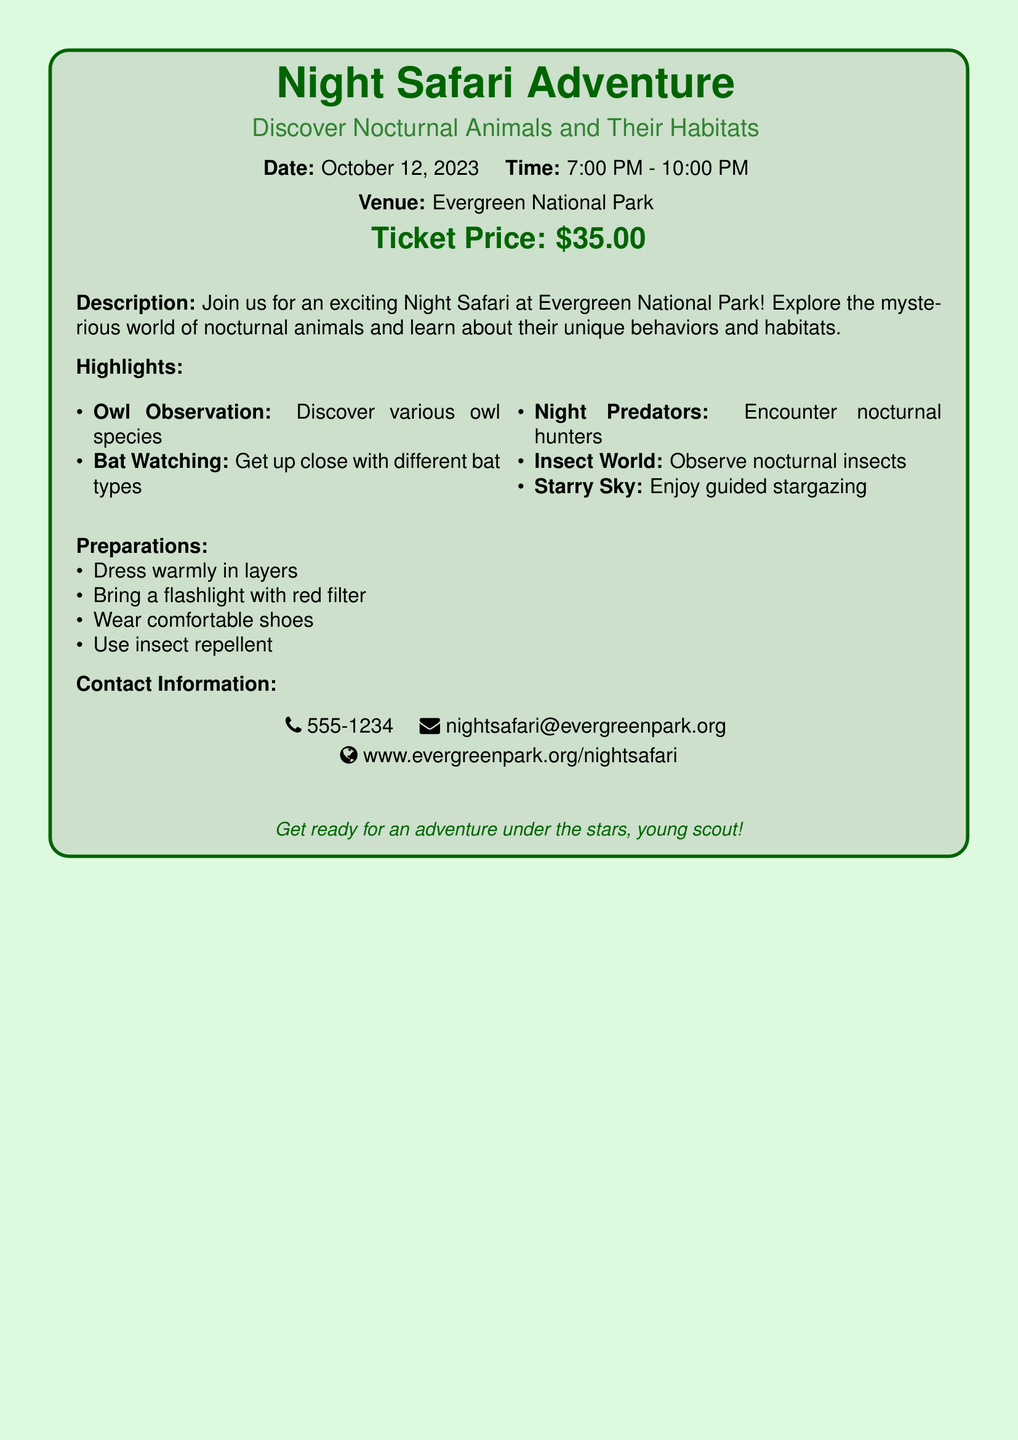What is the date of the Night Safari? The date of the Night Safari is explicitly mentioned in the document.
Answer: October 12, 2023 What time does the Night Safari start? The starting time is specified in the document.
Answer: 7:00 PM What price is listed for a ticket? The ticket price is given clearly in the document.
Answer: $35.00 What is one nocturnal animal that can be observed during the safari? The document lists specific nocturnal animals that can be observed.
Answer: Owl What should you bring to the Night Safari? The document mentions preparations attendees should make, including items to bring.
Answer: Flashlight with red filter What type of terrain should you wear shoes suited for? The document advises on dress and footwear for the event.
Answer: Comfortable shoes How many highlights are mentioned in the document? The number of highlights can be counted from the list provided.
Answer: Five What is the venue for the Night Safari? The venue is specifically stated in the document.
Answer: Evergreen National Park What type of experience can you enjoy besides observing animals? The document includes additional activities related to the safari experience.
Answer: Guided stargazing 